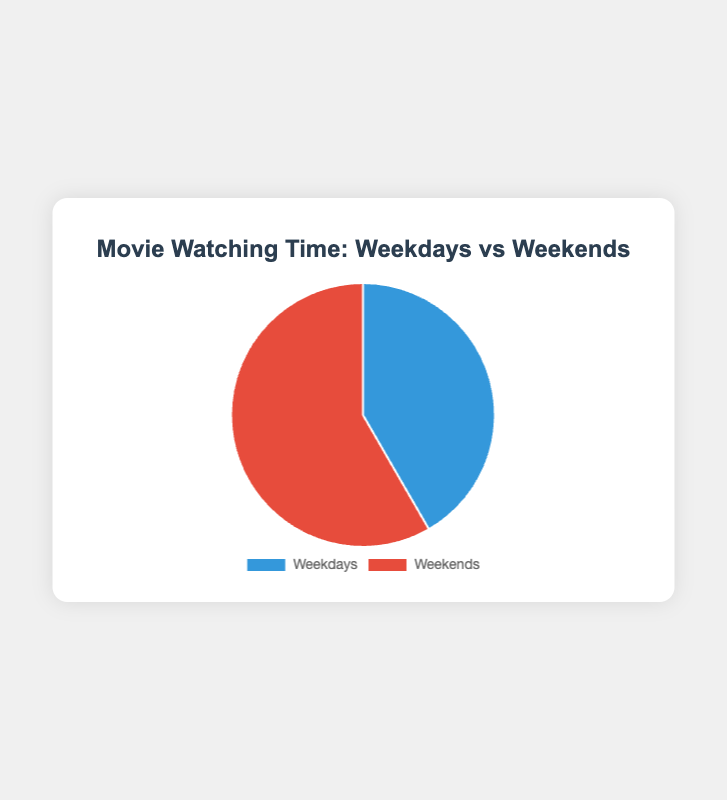What is the total time spent watching movies during the week? To find the total time spent over both weekdays and weekends, sum up the hours spent on each. So, it’s 5 (Weekdays) + 7 (Weekends) = 12 hours
Answer: 12 hours Which period shows more hours spent watching movies, weekdays or weekends? By comparing the two data points, it’s clear that 7 hours is greater than 5 hours. Therefore, more time is spent during the weekends
Answer: Weekends What is the ratio of weekdays to weekends in terms of time spent watching movies? The ratio of Weekdays to Weekends is the amount of time spent on Weekdays divided by the amount of time spent on Weekends, which is 5/7
Answer: 5:7 If you want to reduce your weekend movie watching time by 2 hours, how much time would you then spend on weekends? Subtract 2 hours from the current weekend total of 7 hours, resulting in 7 - 2 = 5 hours
Answer: 5 hours How many more hours are spent watching movies on weekends compared to weekdays? Subtract the hours spent on Weekdays from the hours spent on Weekends, which gives 7 - 5 = 2 hours
Answer: 2 hours What color represents the time spent watching movies during the weekdays? The color representing Weekdays in the chart is blue
Answer: Blue If you split your weekend movie-watching time equally across the two weekend days, how many hours would you spend watching movies each day? Divide the total weekend hours (7) by 2, which results in 7 / 2 = 3.5 hours/day
Answer: 3.5 hours/day What percentage of your total movie watching time is spent during the weekends? To find the percentage, divide the weekend hours by the total hours and then multiply by 100. Thus, (7 / 12) * 100 = 58.33%
Answer: 58.33% Is the difference in hours spent watching movies between weekends and weekdays more than 1 hour? By calculating the difference, 7 hours (Weekends) - 5 hours (Weekdays) = 2 hours, which is more than 1 hour
Answer: Yes If you double your weekday movie-watching time, how much total time would you spend watching movies in a week? Doubling the weekday hours gives 5 * 2 = 10 hours. Adding the weekend hours results in 10 + 7 = 17 hours
Answer: 17 hours 